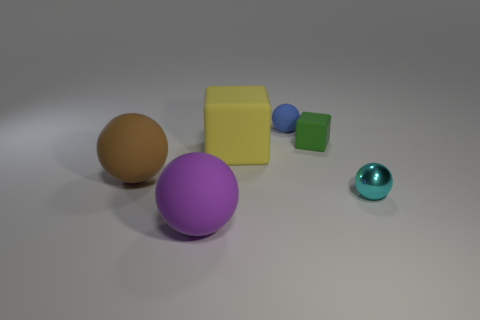Subtract 1 spheres. How many spheres are left? 3 Subtract all red spheres. Subtract all green blocks. How many spheres are left? 4 Add 4 tiny brown metallic blocks. How many objects exist? 10 Subtract all spheres. How many objects are left? 2 Subtract all tiny cyan balls. Subtract all brown spheres. How many objects are left? 4 Add 1 big cubes. How many big cubes are left? 2 Add 5 large purple matte cylinders. How many large purple matte cylinders exist? 5 Subtract 0 blue cubes. How many objects are left? 6 